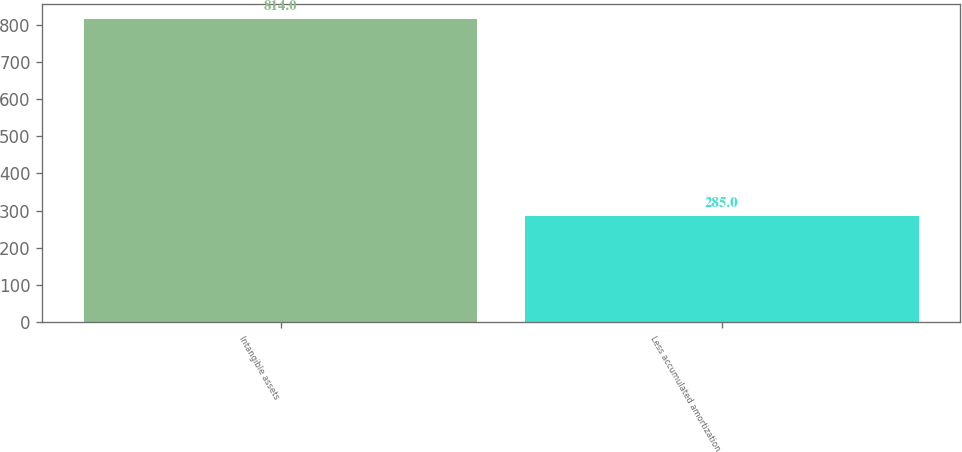Convert chart. <chart><loc_0><loc_0><loc_500><loc_500><bar_chart><fcel>Intangible assets<fcel>Less accumulated amortization<nl><fcel>814<fcel>285<nl></chart> 